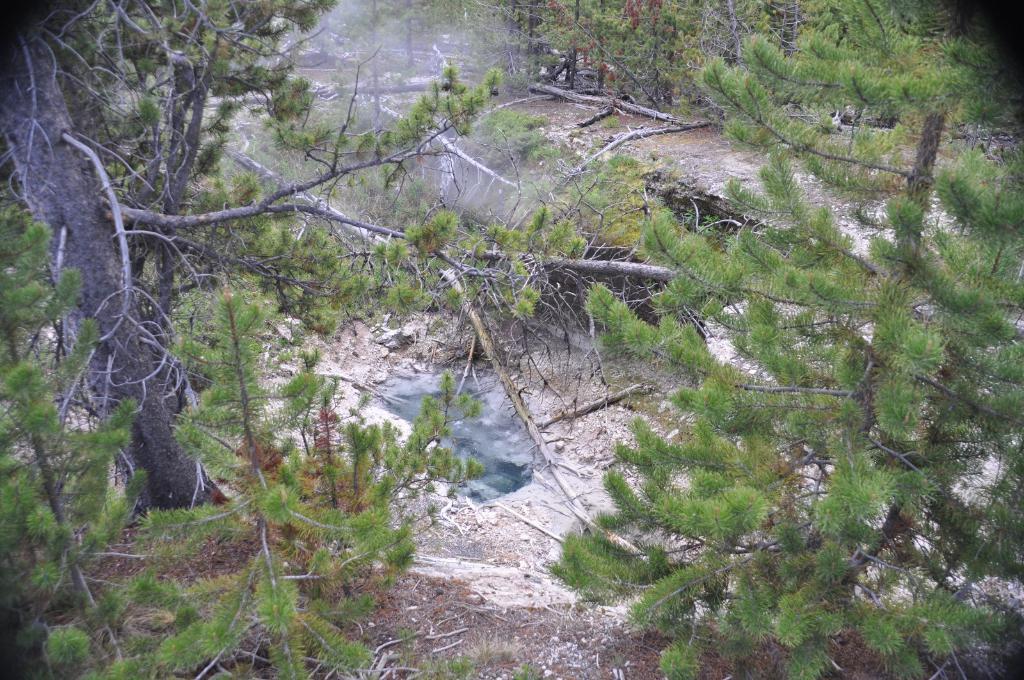Describe this image in one or two sentences. In this image we can see a group of trees and some dried branches. 